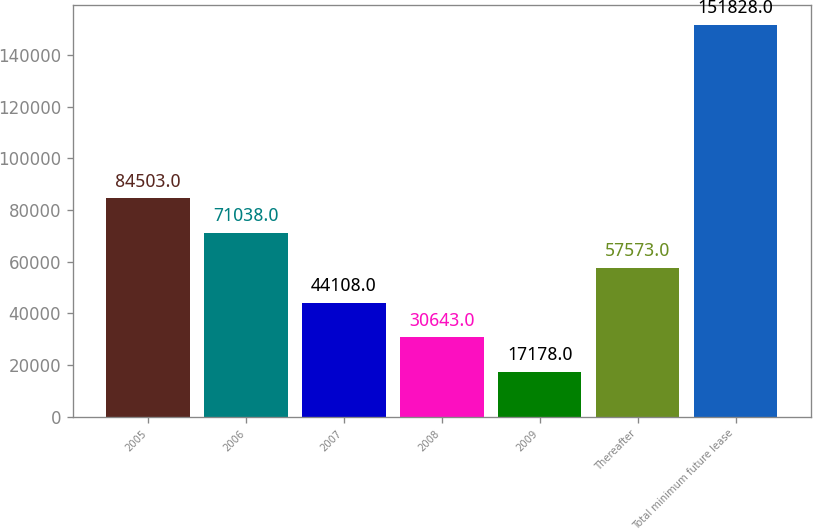Convert chart to OTSL. <chart><loc_0><loc_0><loc_500><loc_500><bar_chart><fcel>2005<fcel>2006<fcel>2007<fcel>2008<fcel>2009<fcel>Thereafter<fcel>Total minimum future lease<nl><fcel>84503<fcel>71038<fcel>44108<fcel>30643<fcel>17178<fcel>57573<fcel>151828<nl></chart> 